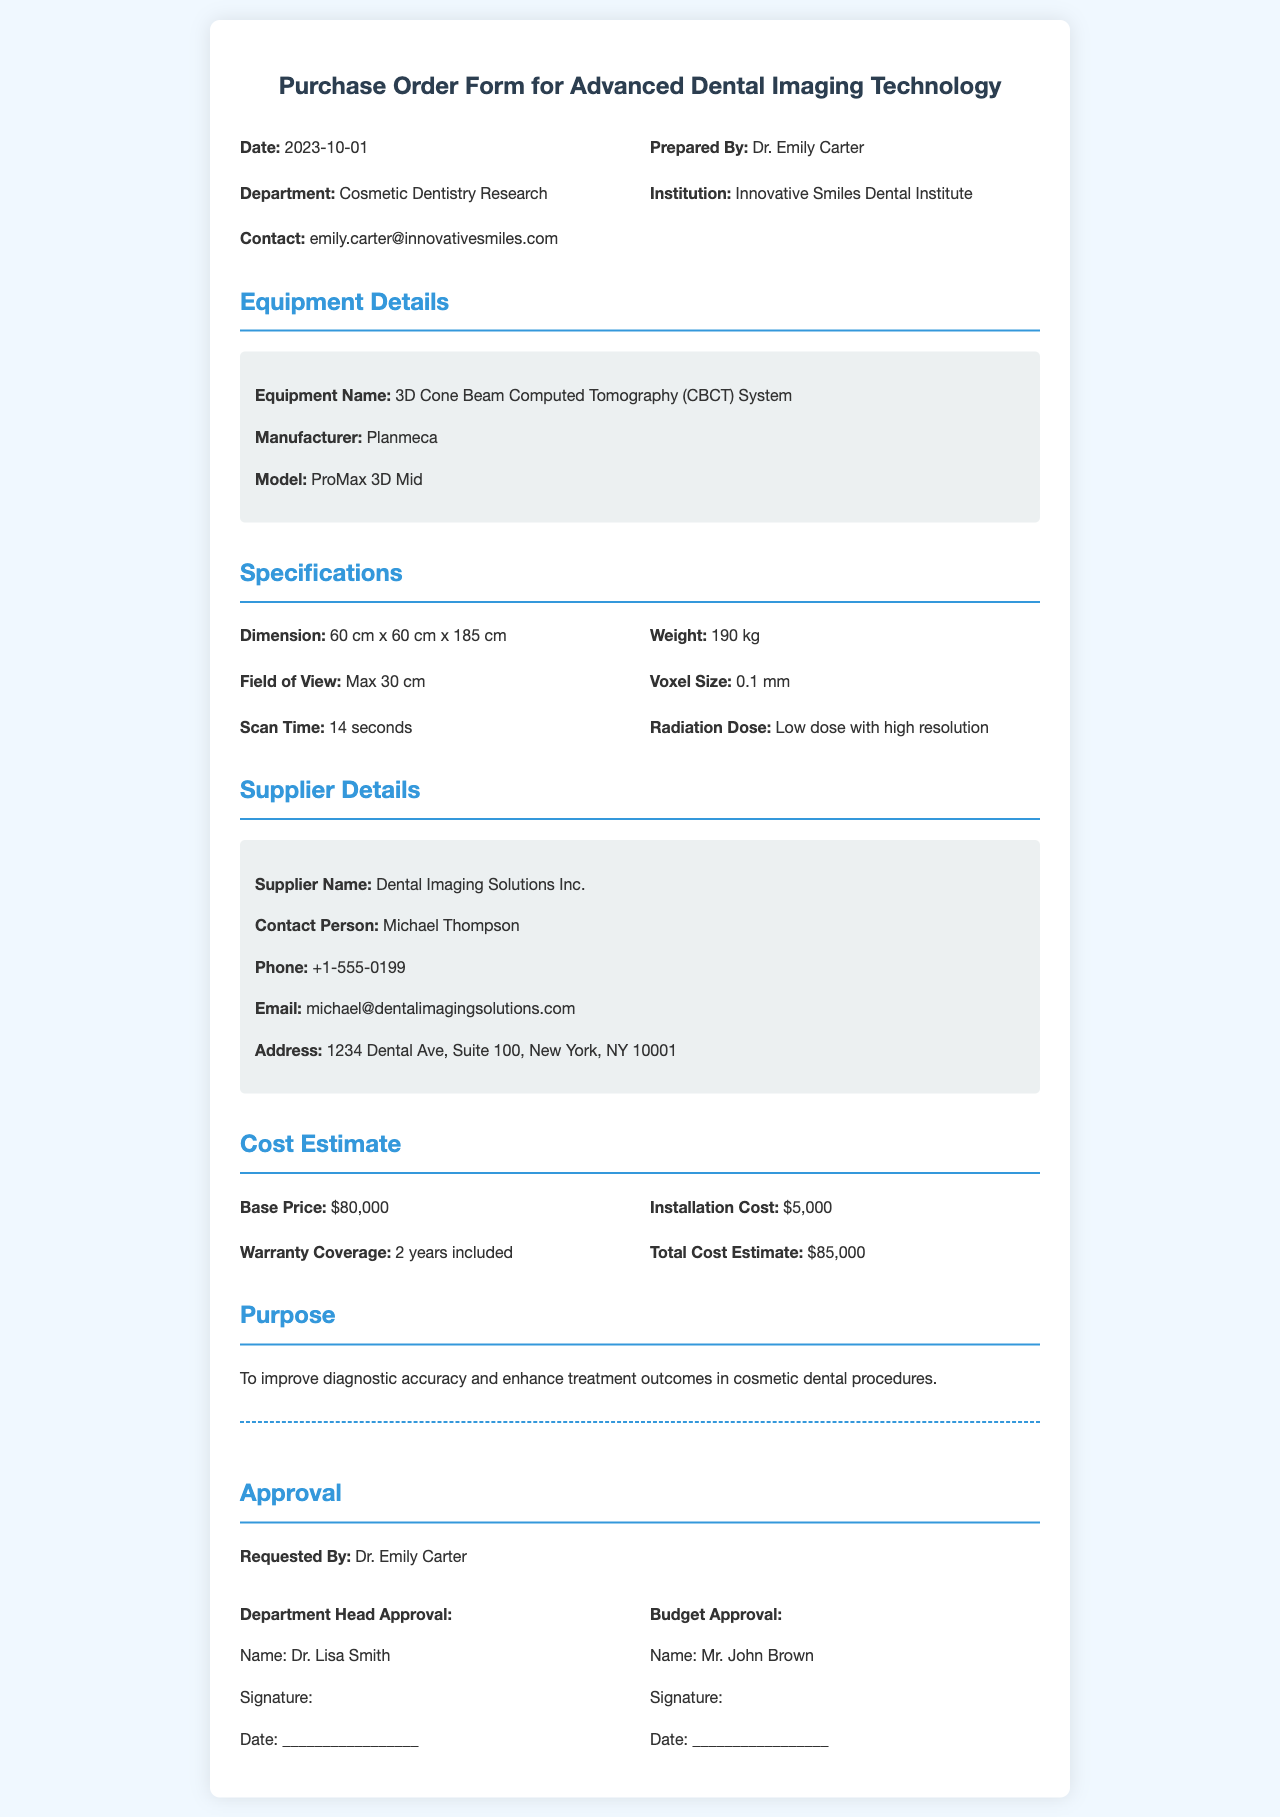What is the equipment name? The equipment name is listed in the document under "Equipment Details," which is 3D Cone Beam Computed Tomography (CBCT) System.
Answer: 3D Cone Beam Computed Tomography (CBCT) System Who is the supplier contact person? The supplier contact person is provided in the Supplier Details section of the document, which is Michael Thompson.
Answer: Michael Thompson What is the weight of the equipment? The weight of the equipment is mentioned in the Specifications section, which states it is 190 kg.
Answer: 190 kg What is the total cost estimate? The total cost estimate can be found in the Cost Estimate section, and it amounts to $85,000.
Answer: $85,000 Who prepared the document? The preparer’s name can be found at the beginning of the document, listed as Dr. Emily Carter.
Answer: Dr. Emily Carter What is included in the warranty coverage? The warranty coverage information is specified in the Cost Estimate section, indicating that it is 2 years included.
Answer: 2 years included What is the main purpose of purchasing this equipment? The purpose can be found in the Purpose section of the document and is to improve diagnostic accuracy and enhance treatment outcomes.
Answer: To improve diagnostic accuracy and enhance treatment outcomes in cosmetic dental procedures What is the installation cost? The installation cost is provided in the Cost Estimate section, which states it is $5,000.
Answer: $5,000 Name of the department associated with this purchase The department is mentioned in the document, specifically under "Department," which is Cosmetic Dentistry Research.
Answer: Cosmetic Dentistry Research 